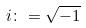Convert formula to latex. <formula><loc_0><loc_0><loc_500><loc_500>i \colon = \sqrt { - 1 }</formula> 